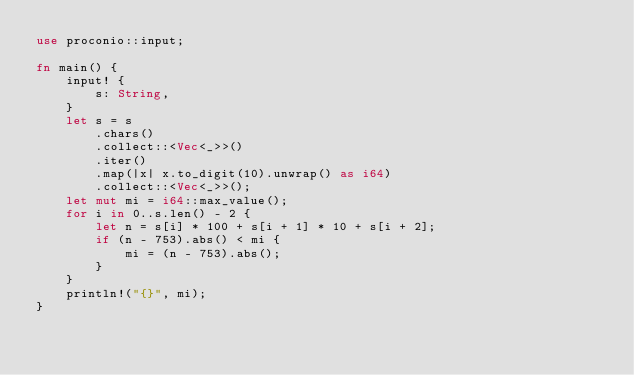<code> <loc_0><loc_0><loc_500><loc_500><_Rust_>use proconio::input;

fn main() {
    input! {
        s: String,
    }
    let s = s
        .chars()
        .collect::<Vec<_>>()
        .iter()
        .map(|x| x.to_digit(10).unwrap() as i64)
        .collect::<Vec<_>>();
    let mut mi = i64::max_value();
    for i in 0..s.len() - 2 {
        let n = s[i] * 100 + s[i + 1] * 10 + s[i + 2];
        if (n - 753).abs() < mi {
            mi = (n - 753).abs();
        }
    }
    println!("{}", mi);
}
</code> 